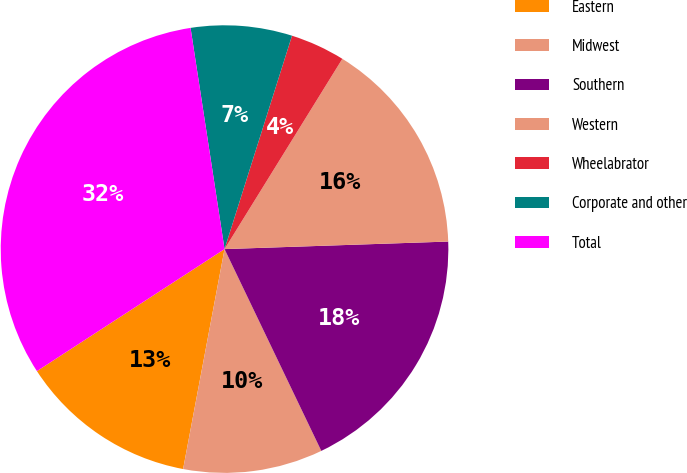Convert chart. <chart><loc_0><loc_0><loc_500><loc_500><pie_chart><fcel>Eastern<fcel>Midwest<fcel>Southern<fcel>Western<fcel>Wheelabrator<fcel>Corporate and other<fcel>Total<nl><fcel>12.86%<fcel>10.08%<fcel>18.42%<fcel>15.64%<fcel>3.95%<fcel>7.3%<fcel>31.75%<nl></chart> 